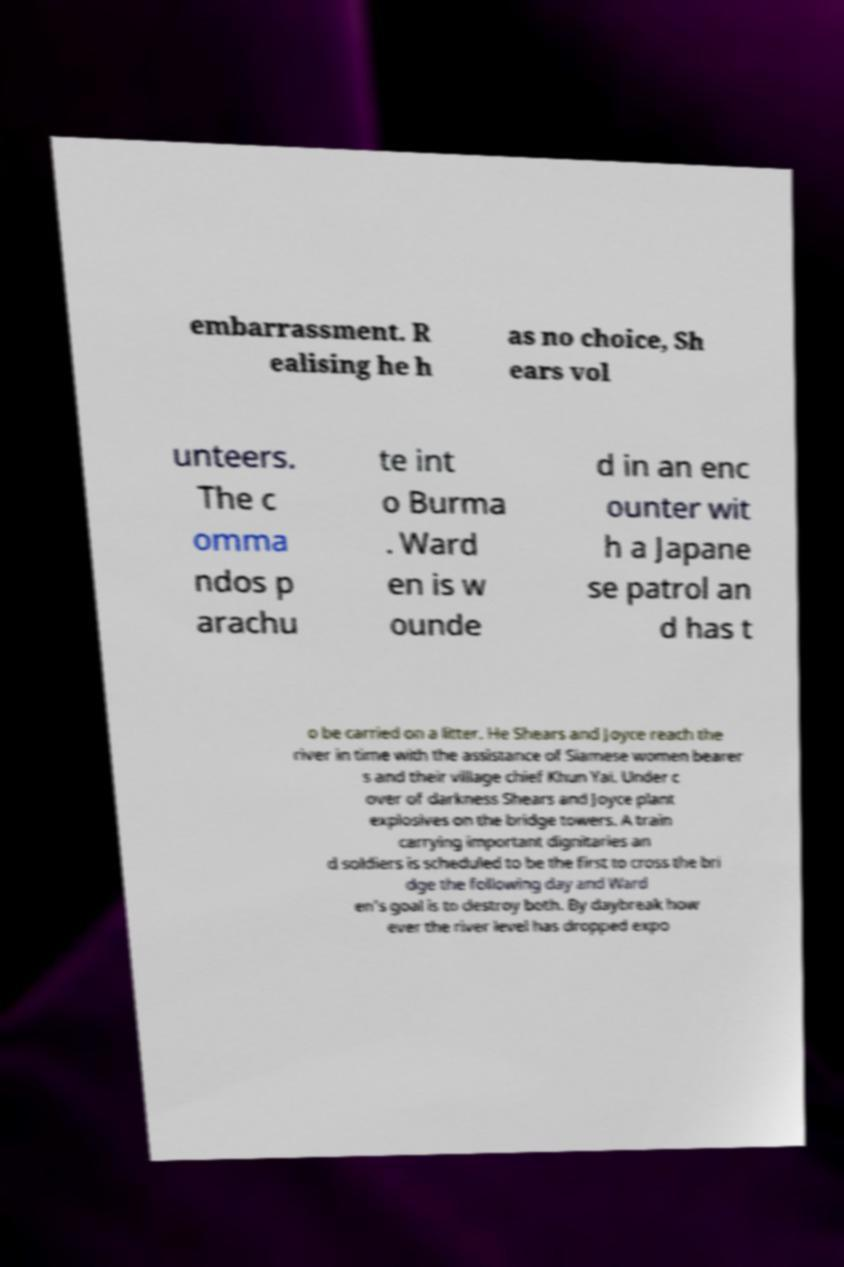Could you extract and type out the text from this image? embarrassment. R ealising he h as no choice, Sh ears vol unteers. The c omma ndos p arachu te int o Burma . Ward en is w ounde d in an enc ounter wit h a Japane se patrol an d has t o be carried on a litter. He Shears and Joyce reach the river in time with the assistance of Siamese women bearer s and their village chief Khun Yai. Under c over of darkness Shears and Joyce plant explosives on the bridge towers. A train carrying important dignitaries an d soldiers is scheduled to be the first to cross the bri dge the following day and Ward en's goal is to destroy both. By daybreak how ever the river level has dropped expo 